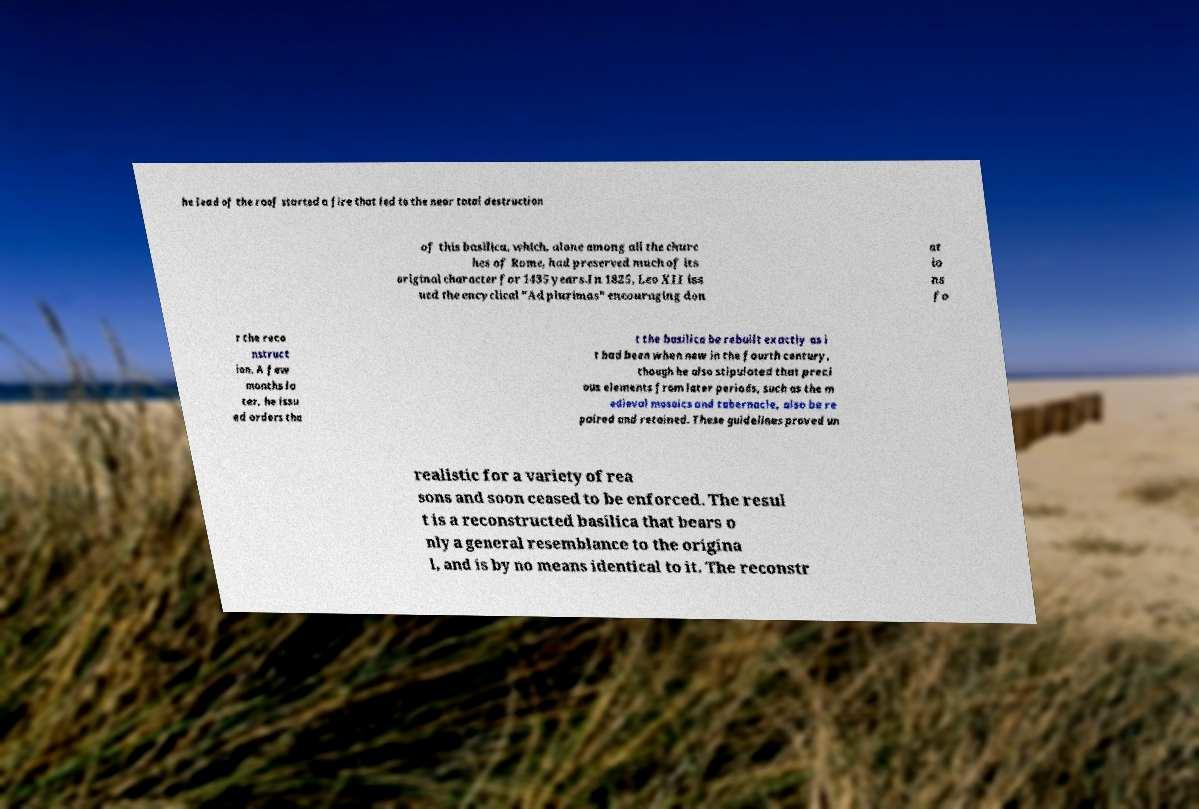I need the written content from this picture converted into text. Can you do that? he lead of the roof started a fire that led to the near total destruction of this basilica, which, alone among all the churc hes of Rome, had preserved much of its original character for 1435 years.In 1825, Leo XII iss ued the encyclical "Ad plurimas" encouraging don at io ns fo r the reco nstruct ion. A few months la ter, he issu ed orders tha t the basilica be rebuilt exactly as i t had been when new in the fourth century, though he also stipulated that preci ous elements from later periods, such as the m edieval mosaics and tabernacle, also be re paired and retained. These guidelines proved un realistic for a variety of rea sons and soon ceased to be enforced. The resul t is a reconstructed basilica that bears o nly a general resemblance to the origina l, and is by no means identical to it. The reconstr 